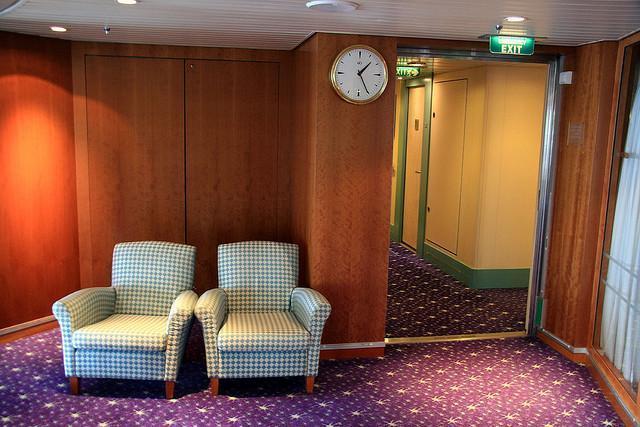How many chairs are there?
Give a very brief answer. 2. How many boats are shown?
Give a very brief answer. 0. 